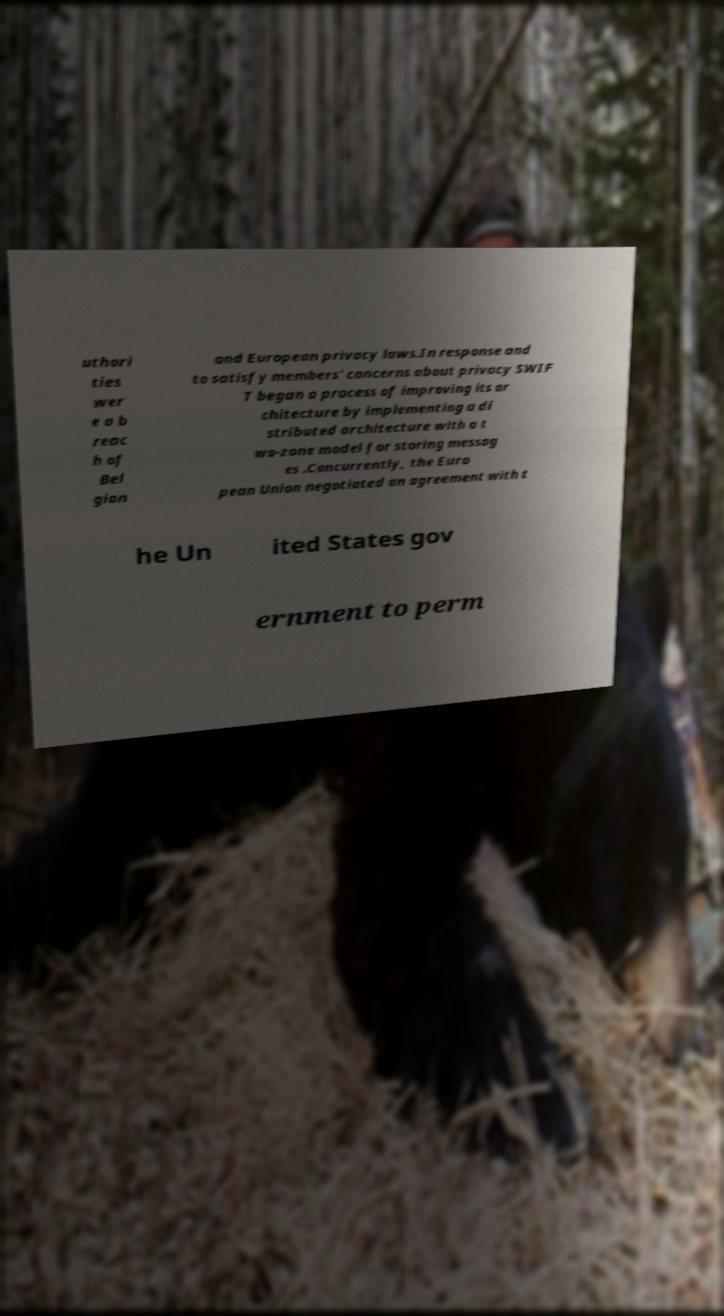Can you read and provide the text displayed in the image?This photo seems to have some interesting text. Can you extract and type it out for me? uthori ties wer e a b reac h of Bel gian and European privacy laws.In response and to satisfy members' concerns about privacy SWIF T began a process of improving its ar chitecture by implementing a di stributed architecture with a t wo-zone model for storing messag es .Concurrently, the Euro pean Union negotiated an agreement with t he Un ited States gov ernment to perm 